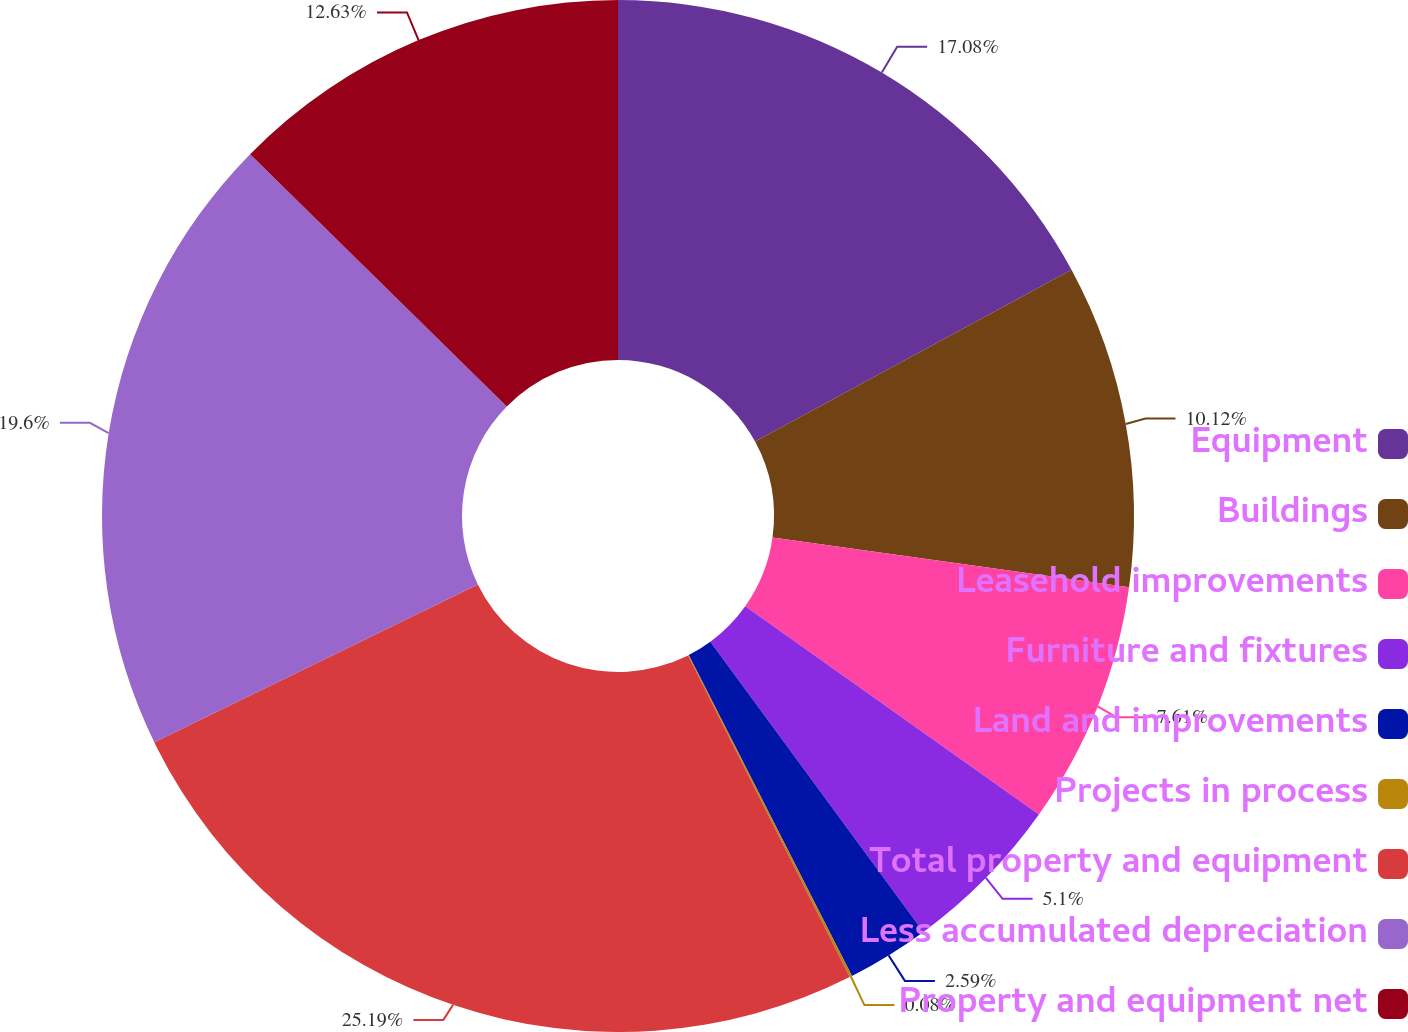Convert chart. <chart><loc_0><loc_0><loc_500><loc_500><pie_chart><fcel>Equipment<fcel>Buildings<fcel>Leasehold improvements<fcel>Furniture and fixtures<fcel>Land and improvements<fcel>Projects in process<fcel>Total property and equipment<fcel>Less accumulated depreciation<fcel>Property and equipment net<nl><fcel>17.08%<fcel>10.12%<fcel>7.61%<fcel>5.1%<fcel>2.59%<fcel>0.08%<fcel>25.18%<fcel>19.59%<fcel>12.63%<nl></chart> 